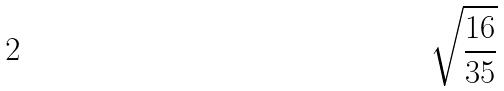Convert formula to latex. <formula><loc_0><loc_0><loc_500><loc_500>\sqrt { \frac { 1 6 } { 3 5 } }</formula> 